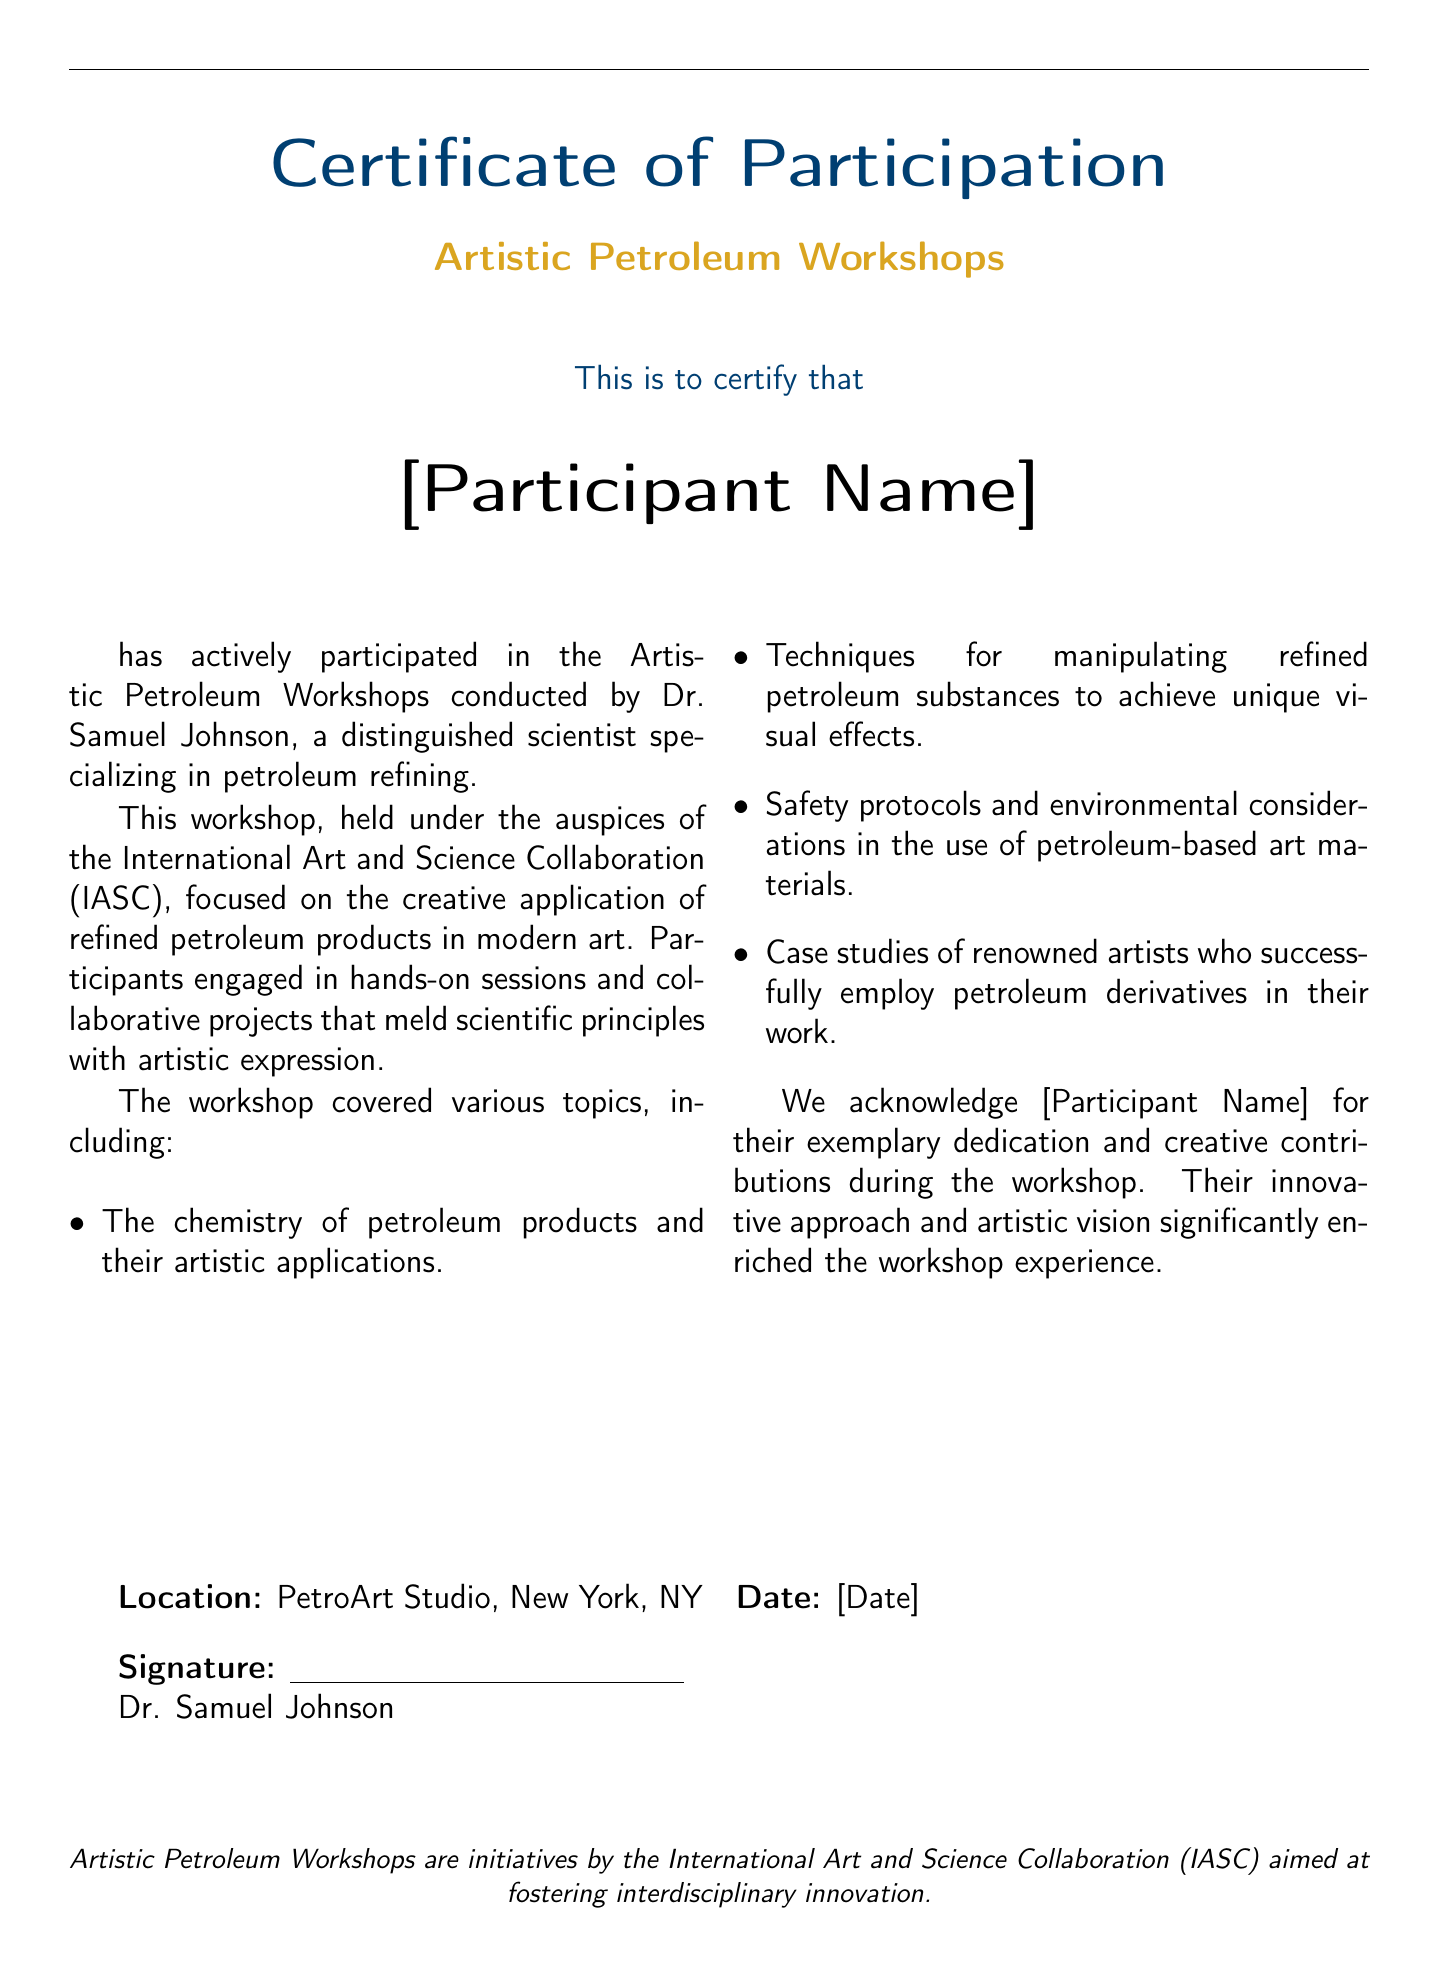What is the name of the workshop? The name of the workshop is specifically stated in the document as "Artistic Petroleum Workshops."
Answer: Artistic Petroleum Workshops Who conducted the workshop? The document mentions that Dr. Samuel Johnson conducted the workshop, and he is identified as a distinguished scientist specializing in petroleum refining.
Answer: Dr. Samuel Johnson Where was the workshop held? The location of the workshop is provided in the document, specifically stating it was held at "PetroArt Studio, New York, NY."
Answer: PetroArt Studio, New York, NY What organization sponsored the workshop? The organization that sponsored the workshop is named as the "International Art and Science Collaboration (IASC)."
Answer: International Art and Science Collaboration (IASC) What date is on the certificate? The specific date is indicated as [Date] in the document, but it does not provide an actual date.
Answer: [Date] What is one topic covered in the workshop? The document lists several topics, and one example provided is "The chemistry of petroleum products and their artistic applications."
Answer: The chemistry of petroleum products and their artistic applications What is a key focus of the workshops? The document indicates that the key focus of the workshops is on the "creative application of refined petroleum products in modern art."
Answer: creative application of refined petroleum products in modern art What kind of contributions did the participant make? The document notes that the participant made "exemplary dedication and creative contributions" during the workshop.
Answer: exemplary dedication and creative contributions Who acknowledges the participant's contributions? The document states that Dr. Samuel Johnson acknowledges the participant for their contributions.
Answer: Dr. Samuel Johnson 